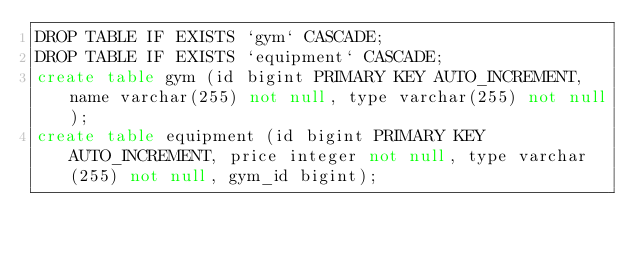Convert code to text. <code><loc_0><loc_0><loc_500><loc_500><_SQL_>DROP TABLE IF EXISTS `gym` CASCADE;
DROP TABLE IF EXISTS `equipment` CASCADE;
create table gym (id bigint PRIMARY KEY AUTO_INCREMENT, name varchar(255) not null, type varchar(255) not null);
create table equipment (id bigint PRIMARY KEY AUTO_INCREMENT, price integer not null, type varchar(255) not null, gym_id bigint);
</code> 